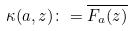Convert formula to latex. <formula><loc_0><loc_0><loc_500><loc_500>\kappa ( a , z ) \colon = \overline { F _ { a } ( z ) }</formula> 